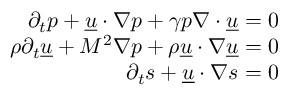<formula> <loc_0><loc_0><loc_500><loc_500>\begin{array} { r } { \partial _ { t } p + \underline { u } { \cdot } \nabla p + \gamma p \nabla { \cdot } \underline { u } = 0 } \\ { \rho \partial _ { t } \underline { u } + M ^ { 2 } \nabla p + \rho \underline { u } { \cdot } \nabla \underline { u } = 0 } \\ { \partial _ { t } s + \underline { u } { \cdot } \nabla s = 0 } \end{array}</formula> 